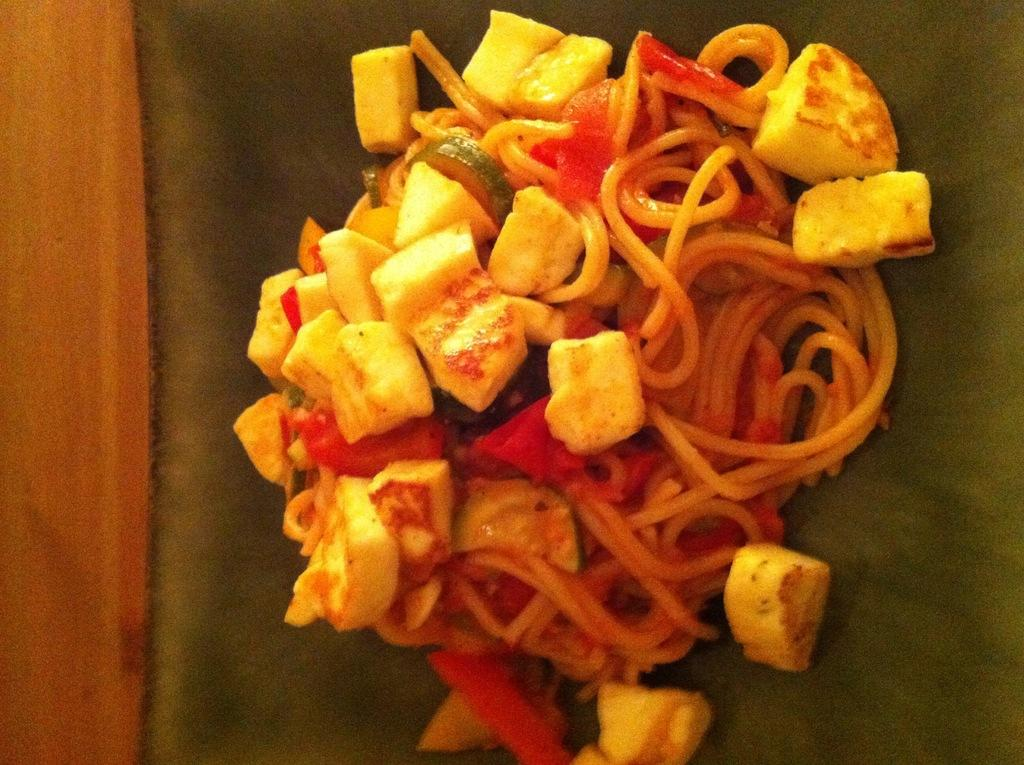What type of food can be seen in the image? There is food in the image, specifically noodles. What color are the noodles in the image? The food, including the noodles, is in yellow color. How does the beginner learn to cook the yellow noodles in the image? The image does not provide information on how to cook the noodles or any learning process, as it only shows the food in yellow color. 